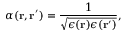Convert formula to latex. <formula><loc_0><loc_0><loc_500><loc_500>\alpha ( r , r ^ { \prime } ) = \frac { 1 } { \sqrt { \epsilon ( r ) \epsilon ( r ^ { \prime } ) } } ,</formula> 